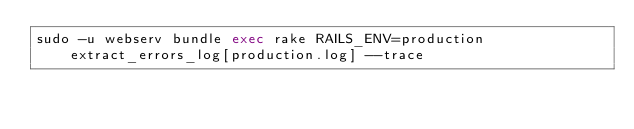Convert code to text. <code><loc_0><loc_0><loc_500><loc_500><_Bash_>sudo -u webserv bundle exec rake RAILS_ENV=production extract_errors_log[production.log] --trace</code> 